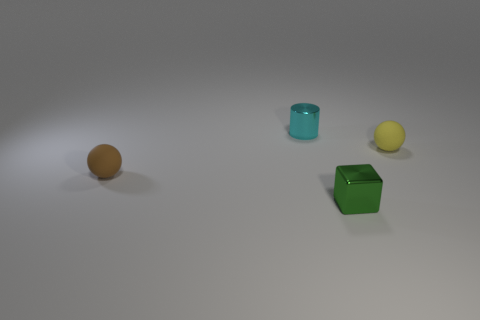What can you infer about the setting where these objects are placed? The objects are placed on a smooth, even surface, which has a gentle gradient of light, perhaps suggesting they are in a controlled, artificial setting such as a photography studio or a 3D-rendering environment. The neutral background helps focus attention on the objects themselves. 